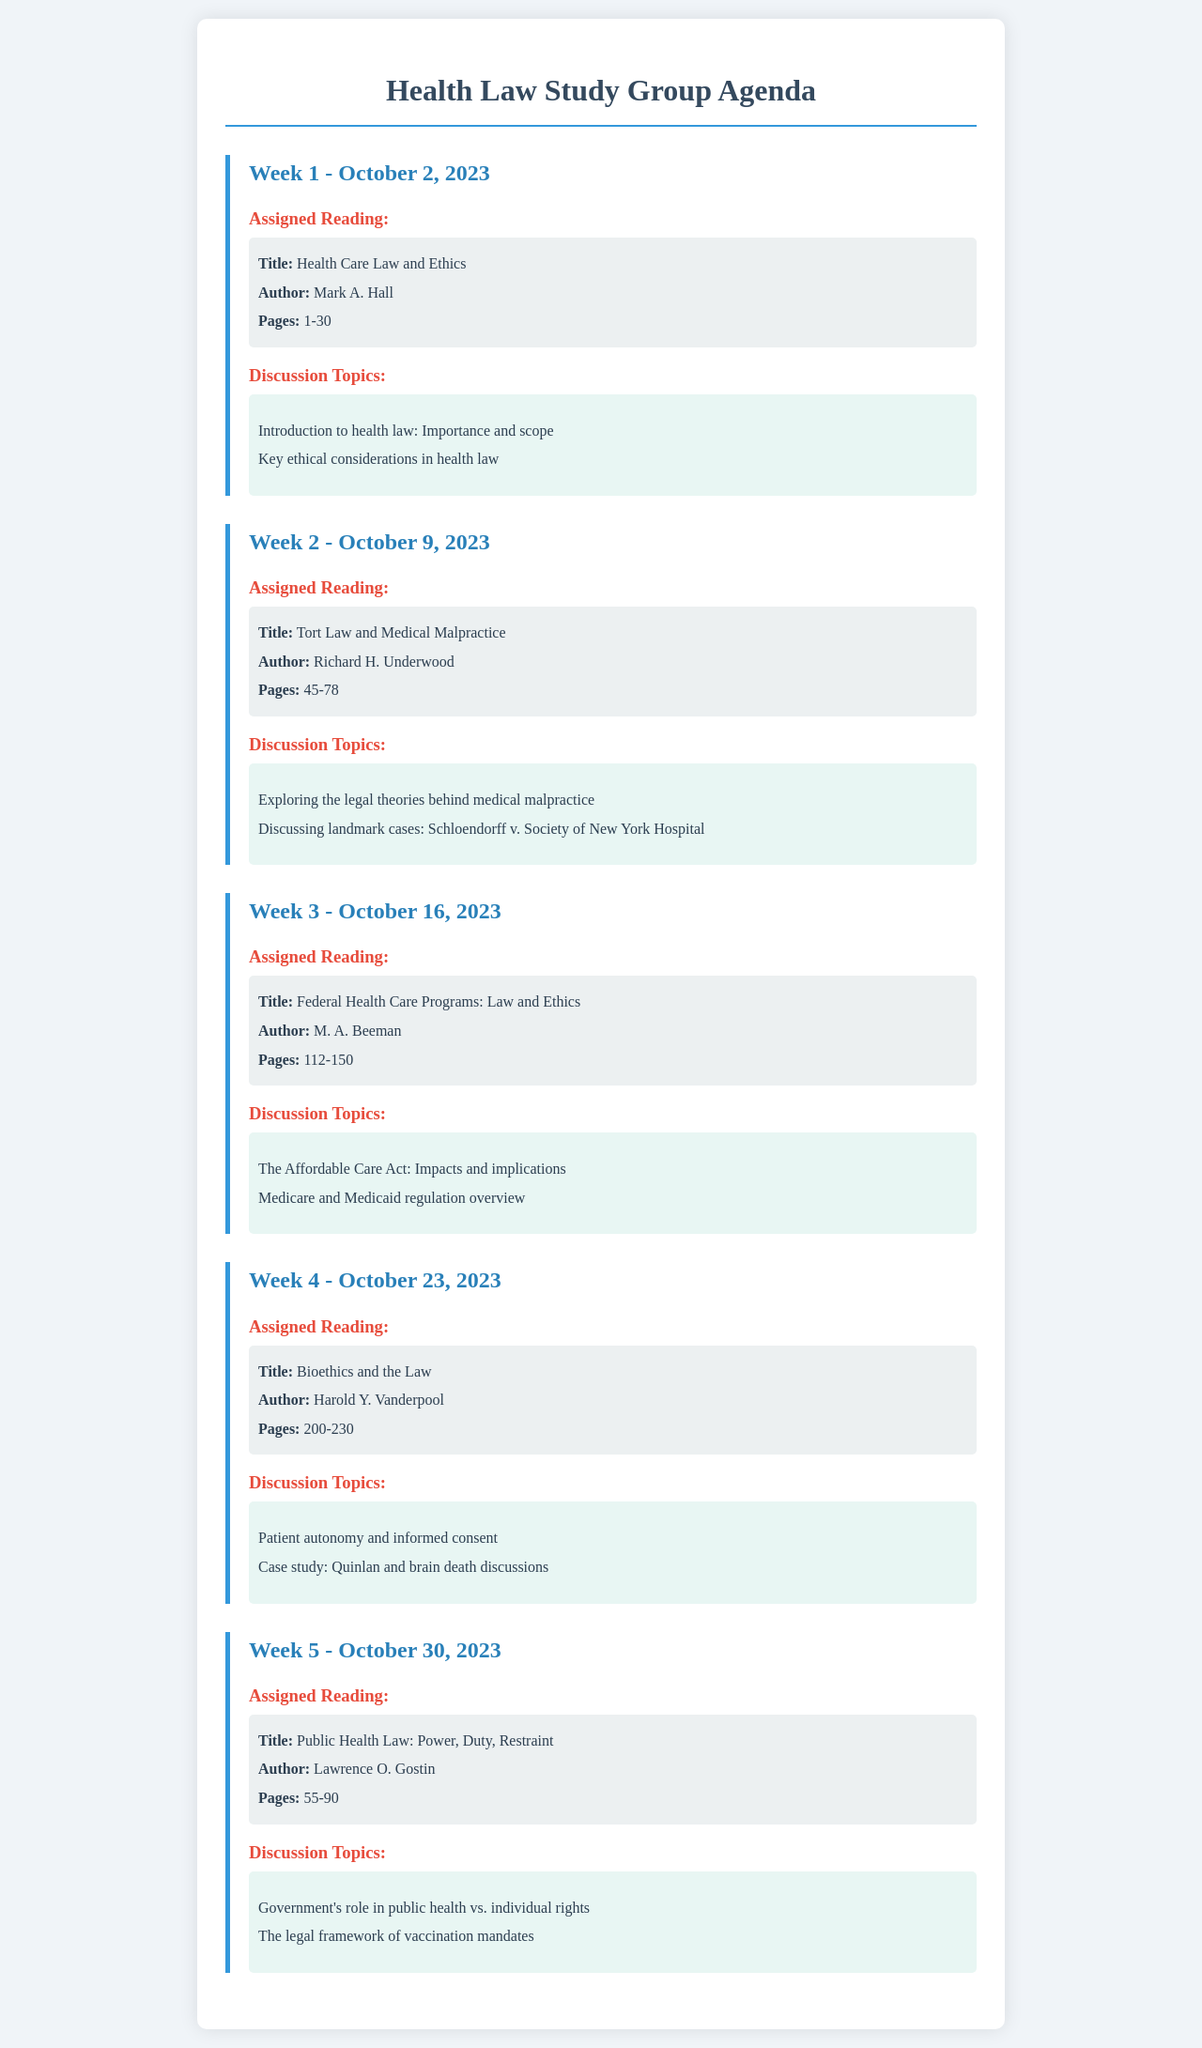What is the title of the reading for Week 1? The title of the reading for Week 1 is found in the assigned reading section for that week.
Answer: Health Care Law and Ethics Who is the author of the Week 3 reading? The author of the Week 3 reading is listed in the assigned reading section for that week.
Answer: M. A. Beeman What date is Week 4 scheduled for? The date for Week 4 is specified within the headline of that week’s section in the agenda.
Answer: October 23, 2023 How many pages are assigned for the Week 2 reading? The number of pages for the Week 2 reading is provided in that week’s assigned reading details.
Answer: 45-78 What is one of the discussion topics for Week 5? Discussion topics for each week are listed in the corresponding section; one topic for Week 5 needs to be identified.
Answer: Government's role in public health vs. individual rights What was the focus of the Week 4 case study discussion? The case study discussed in Week 4 is mentioned in the topics section for that week.
Answer: Quinlan and brain death discussions What legal case is discussed in Week 2? The legal case highlighted in Week 2's discussion topics is stated in that section.
Answer: Schloendorff v. Society of New York Hospital What overarching theme is addressed in Week 3? The overarching theme for Week 3 relates to the focus of the reading and the associated discussion topics.
Answer: The Affordable Care Act: Impacts and implications What is the primary subject of the reading in Week 5? The primary subject of the Week 5 reading is found in the title provided for that week's assigned reading section.
Answer: Public Health Law: Power, Duty, Restraint 